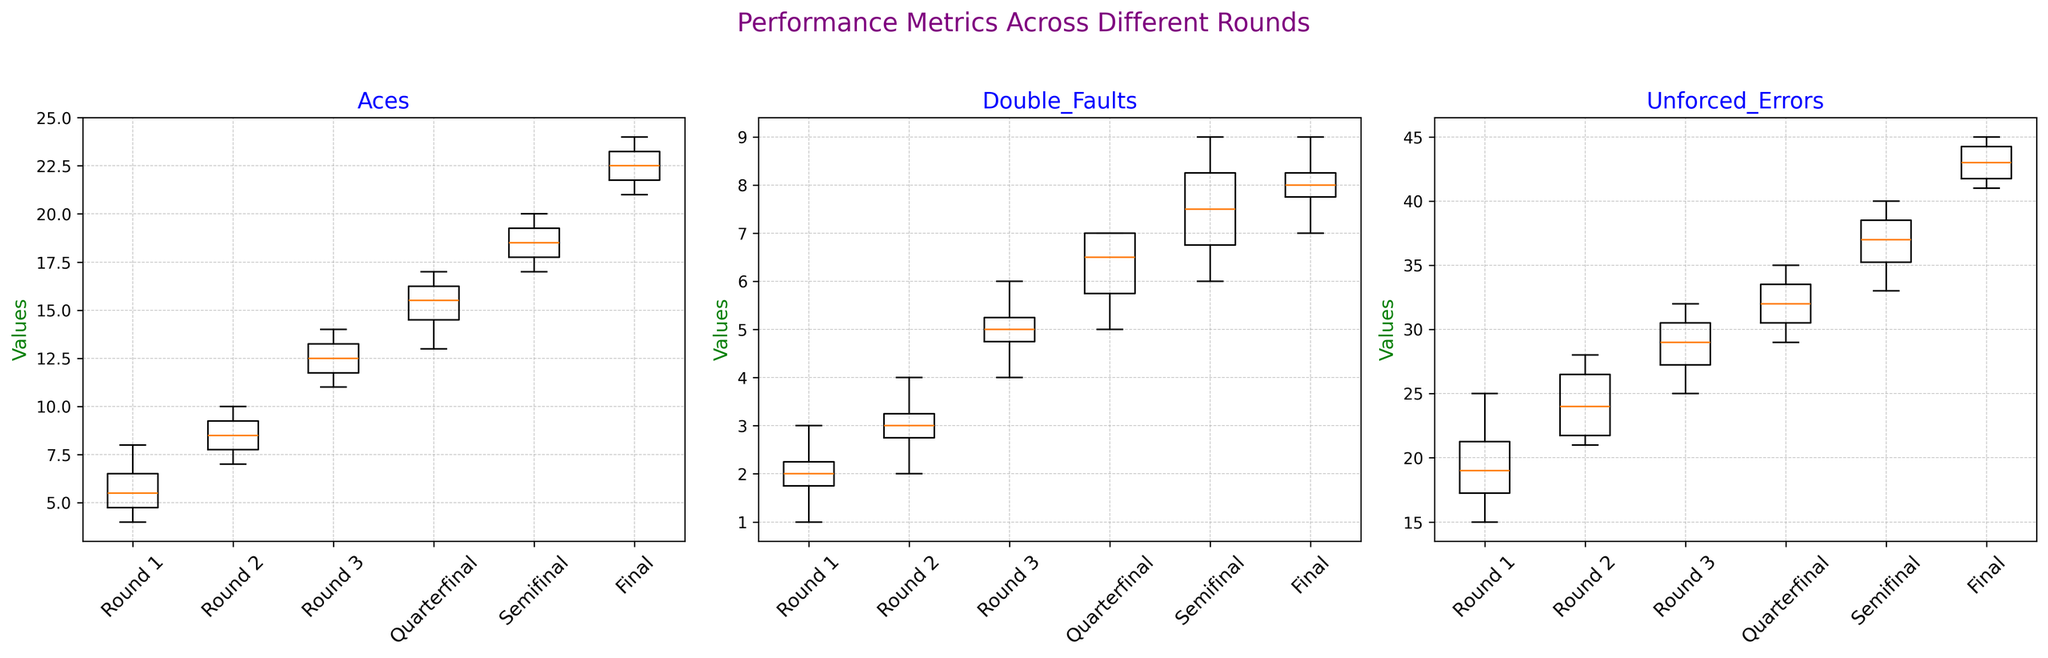What's the median number of Aces in the Final round? Look at the box plot for Aces in the Final round. The median is represented by the line inside the box. The number corresponding to this line is the median value.
Answer: 22.5 In which round is the median number of Double Faults the highest? Examine the line inside the boxes for Double Faults across all rounds. The highest median line will indicate the round with the highest median value.
Answer: Semifinal Which round has the widest spread for Unforced Errors? Observe the range of the boxes and whiskers in the Unforced Errors plots for each round. The round with the longest distance between the minimum and maximum values has the widest spread.
Answer: Semifinal How do the medians of Aces in Round 1 compare to those in the Quarterfinals? Look at the lines inside the Aces boxes for both Round 1 and Quarterfinals. Compare their positions on the y-axis.
Answer: Higher in Quarterfinals Calculate the interquartile range (IQR) for Unforced Errors in Round 2. Identify the top and bottom edges of the box for Unforced Errors in Round 2, which represent the third and first quartiles (Q3 and Q1), respectively. Subtract Q1 from Q3 to find the IQR.
Answer: 5 Which round shows the least variability in Double Faults? Check the boxes and whiskers in the Double Faults plots for each round. The round with the shortest box and whiskers represents the least variability.
Answer: Round 1 Are there any rounds where the minimum value of Aces is higher than the maximum value of Aces in another round? Compare the lower whiskers (minimum values) of the Aces plot for each round with the upper whiskers (maximum values) of the other rounds.
Answer: Yes, Final vs Round 1 What is the median value of Unforced Errors in Round 3 and how does it compare to Round 1? Find the median lines within the boxes for Unforced Errors in both Round 3 and Round 1, and compare their positions.
Answer: Higher in Round 3 Which round has the highest outlier value for Aces? Look for dots outside the whiskers in the Aces plot. The round with the highest dot represents the highest outlier value.
Answer: Final 